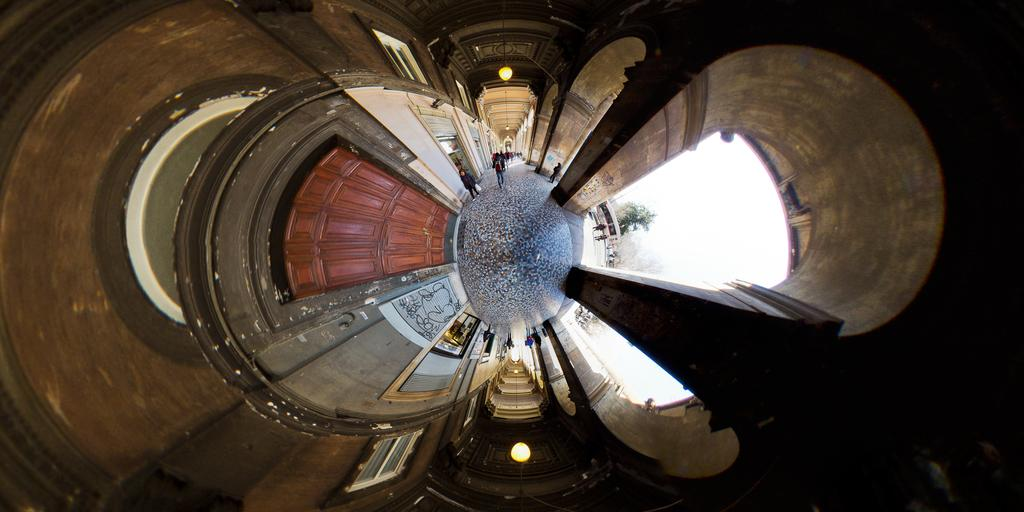What are the people in the image doing? The people in the image are walking. What structure can be seen in the image? There is a door in the image. What type of vegetation is present in the image? There is a tree in the image. What type of objects are present in the image? There are frames in the image. What architectural feature is visible in the image? There is a roof visible in the image. What can be seen in the image that indicates the presence of light? There is light visible in the image. Can you see a hose being used by the people in the image? There is no hose present in the image. What type of lace is draped over the tree in the image? There is no lace present in the image. 